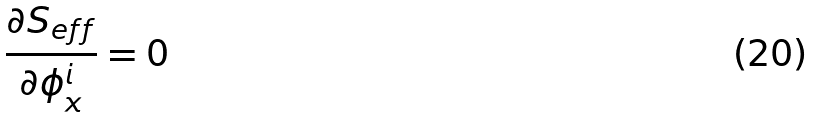<formula> <loc_0><loc_0><loc_500><loc_500>\frac { \partial S _ { e f f } } { \partial \phi _ { x } ^ { i } } = 0</formula> 